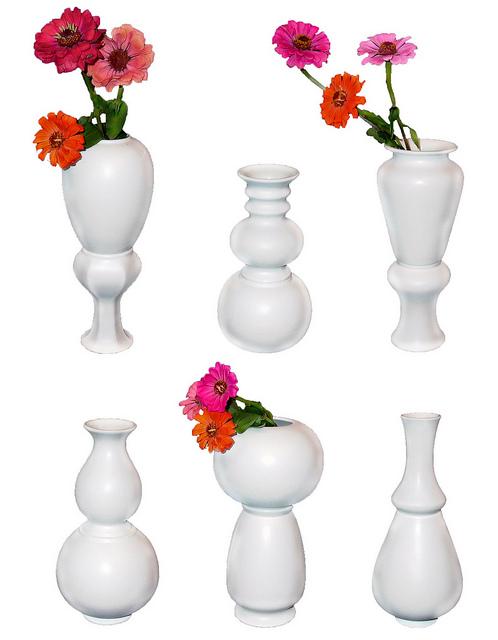Could these vases be painted?
Write a very short answer. Yes. What is in the vase?
Answer briefly. Flowers. How many different vases are there?
Keep it brief. 6. 